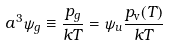Convert formula to latex. <formula><loc_0><loc_0><loc_500><loc_500>a ^ { 3 } \psi _ { g } \equiv \frac { p _ { g } } { k T } = \psi _ { u } \frac { p _ { \text {v} } ( T ) } { k T }</formula> 